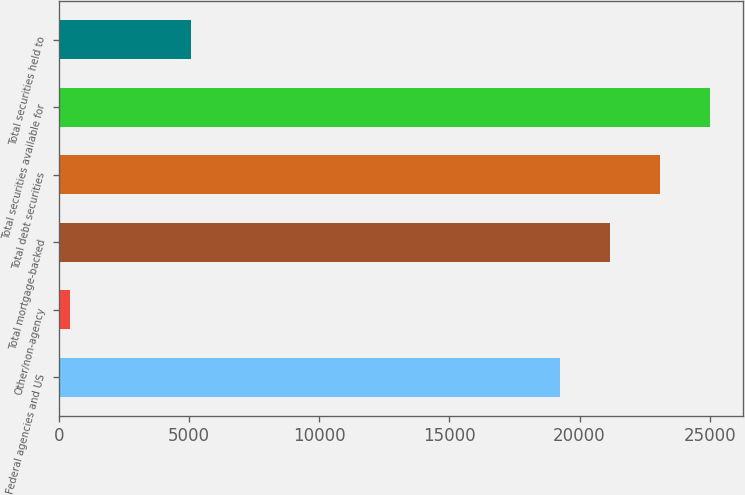Convert chart to OTSL. <chart><loc_0><loc_0><loc_500><loc_500><bar_chart><fcel>Federal agencies and US<fcel>Other/non-agency<fcel>Total mortgage-backed<fcel>Total debt securities<fcel>Total securities available for<fcel>Total securities held to<nl><fcel>19231<fcel>427<fcel>21159.6<fcel>23088.2<fcel>25016.8<fcel>5071<nl></chart> 